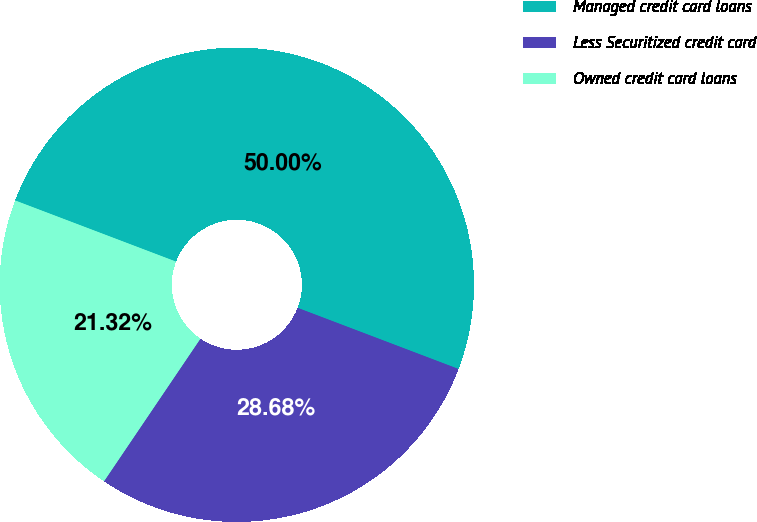<chart> <loc_0><loc_0><loc_500><loc_500><pie_chart><fcel>Managed credit card loans<fcel>Less Securitized credit card<fcel>Owned credit card loans<nl><fcel>50.0%<fcel>28.68%<fcel>21.32%<nl></chart> 